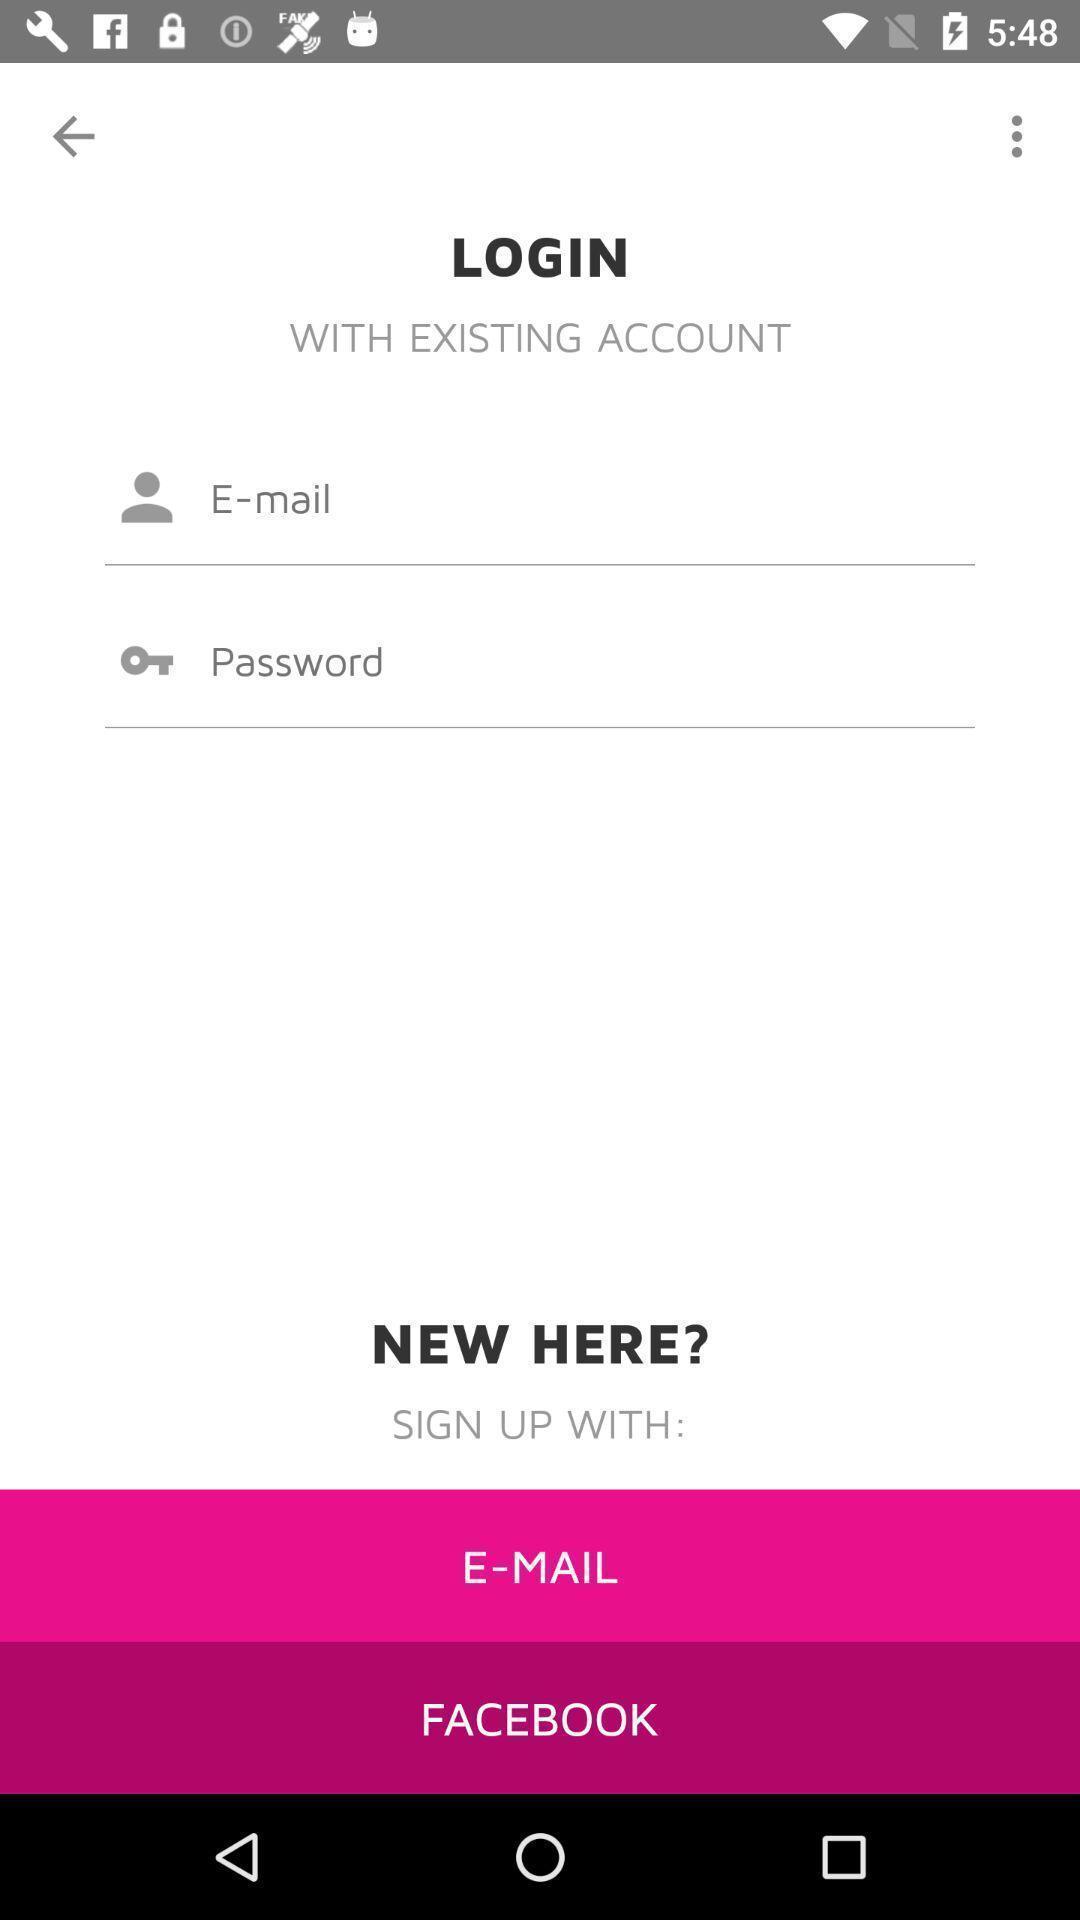Describe the content in this image. Welcome page displaying login details. 